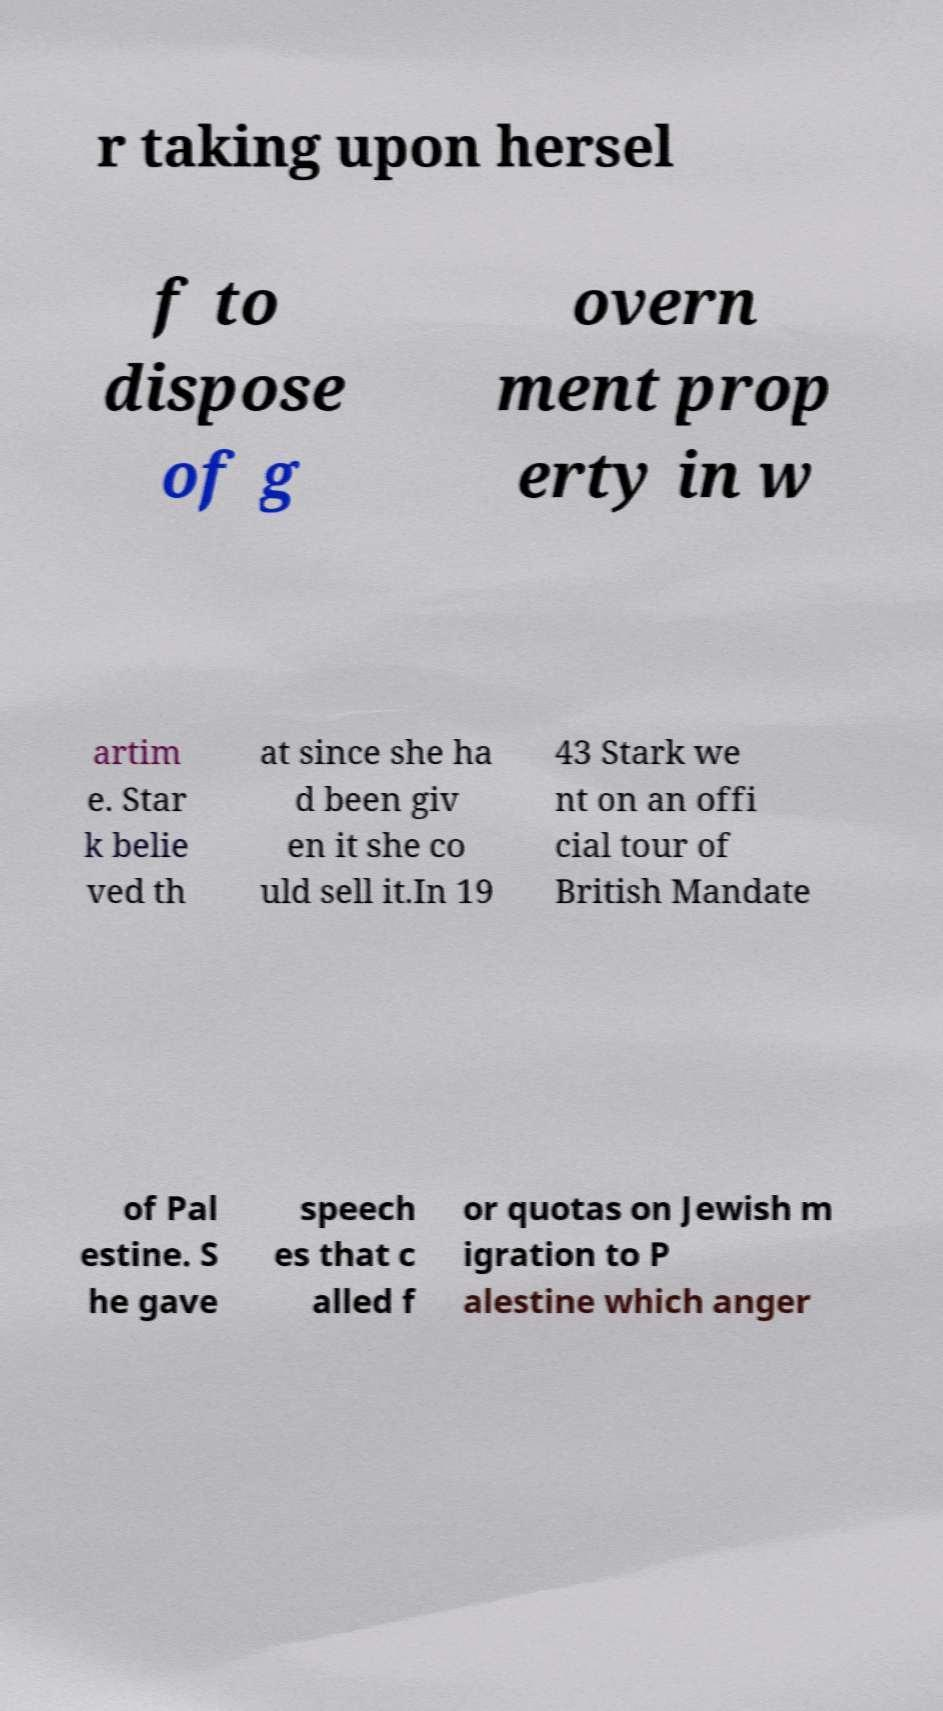Please read and relay the text visible in this image. What does it say? r taking upon hersel f to dispose of g overn ment prop erty in w artim e. Star k belie ved th at since she ha d been giv en it she co uld sell it.In 19 43 Stark we nt on an offi cial tour of British Mandate of Pal estine. S he gave speech es that c alled f or quotas on Jewish m igration to P alestine which anger 